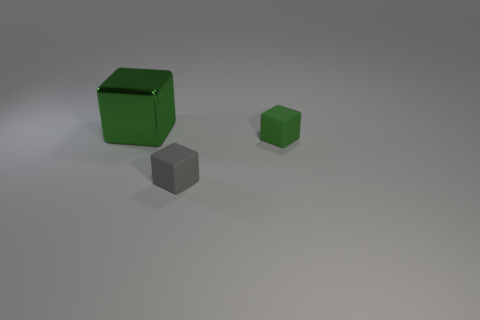Add 2 big things. How many objects exist? 5 Add 1 small gray matte things. How many small gray matte things are left? 2 Add 1 blue things. How many blue things exist? 1 Subtract 0 brown balls. How many objects are left? 3 Subtract all large purple metal cubes. Subtract all large green things. How many objects are left? 2 